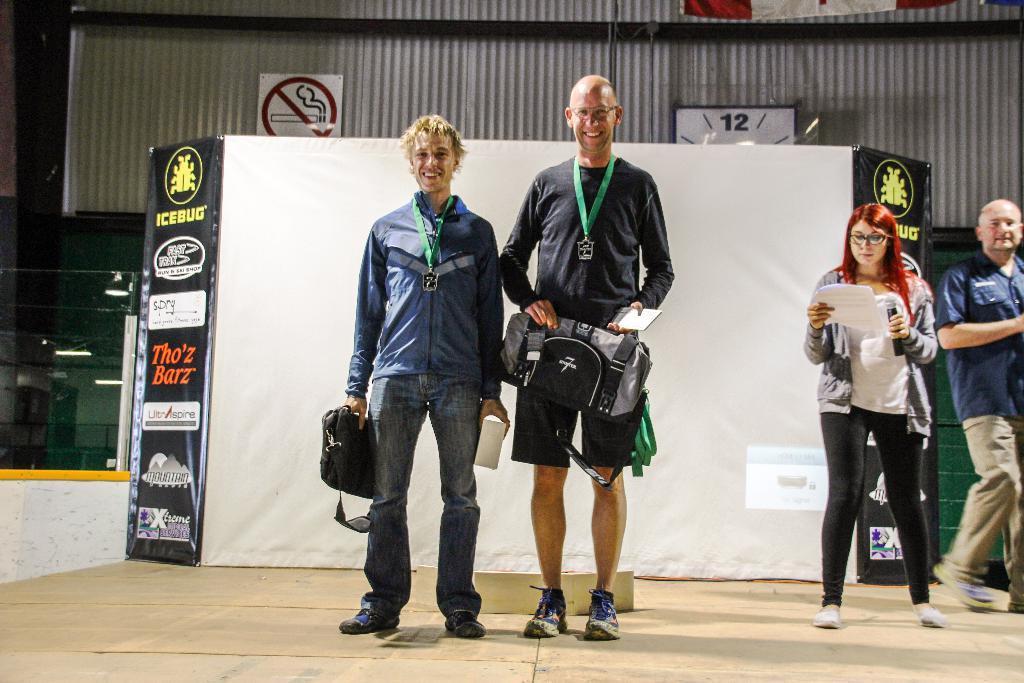How would you summarize this image in a sentence or two? In the image there are two men standing in the foreground and they are holding bags and other objects, behind them there are logos and on the right side there are two other people, in the background there is no smoking board and a clock attached to a surface. 